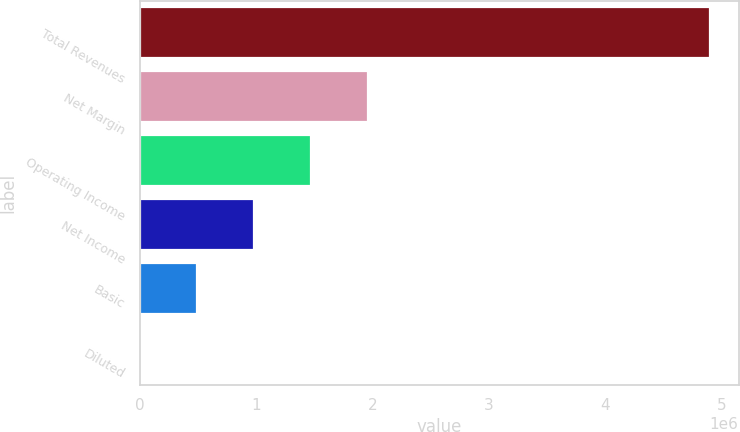Convert chart. <chart><loc_0><loc_0><loc_500><loc_500><bar_chart><fcel>Total Revenues<fcel>Net Margin<fcel>Operating Income<fcel>Net Income<fcel>Basic<fcel>Diluted<nl><fcel>4.90208e+06<fcel>1.96083e+06<fcel>1.47062e+06<fcel>980416<fcel>490209<fcel>1.36<nl></chart> 